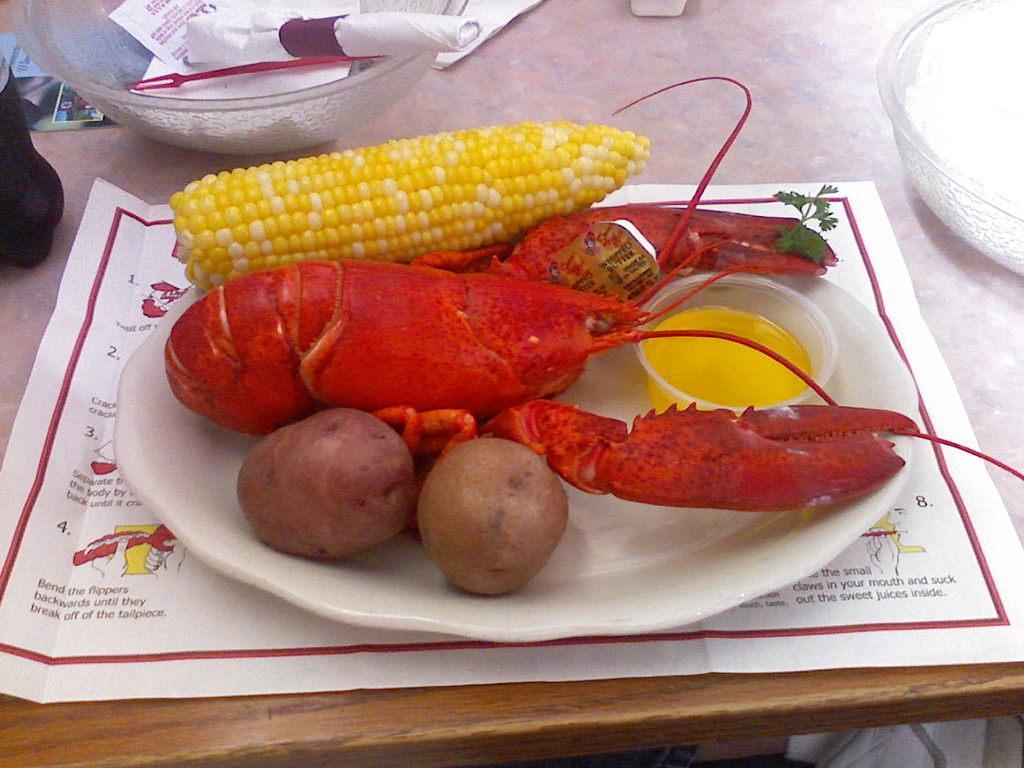Please provide a concise description of this image. In this image we can see food items in a plate. There are bowls and there is a paper on the table. 